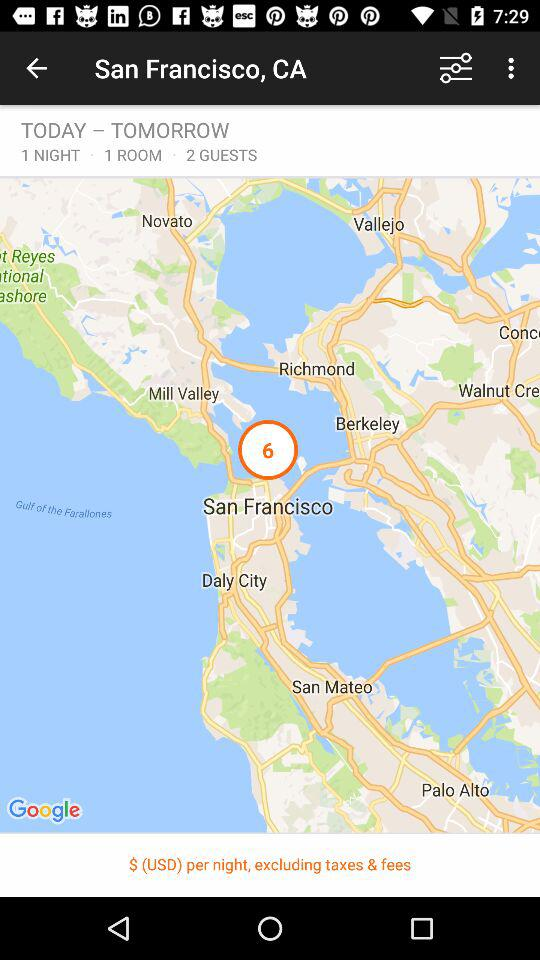How many more guests are there than rooms?
Answer the question using a single word or phrase. 1 